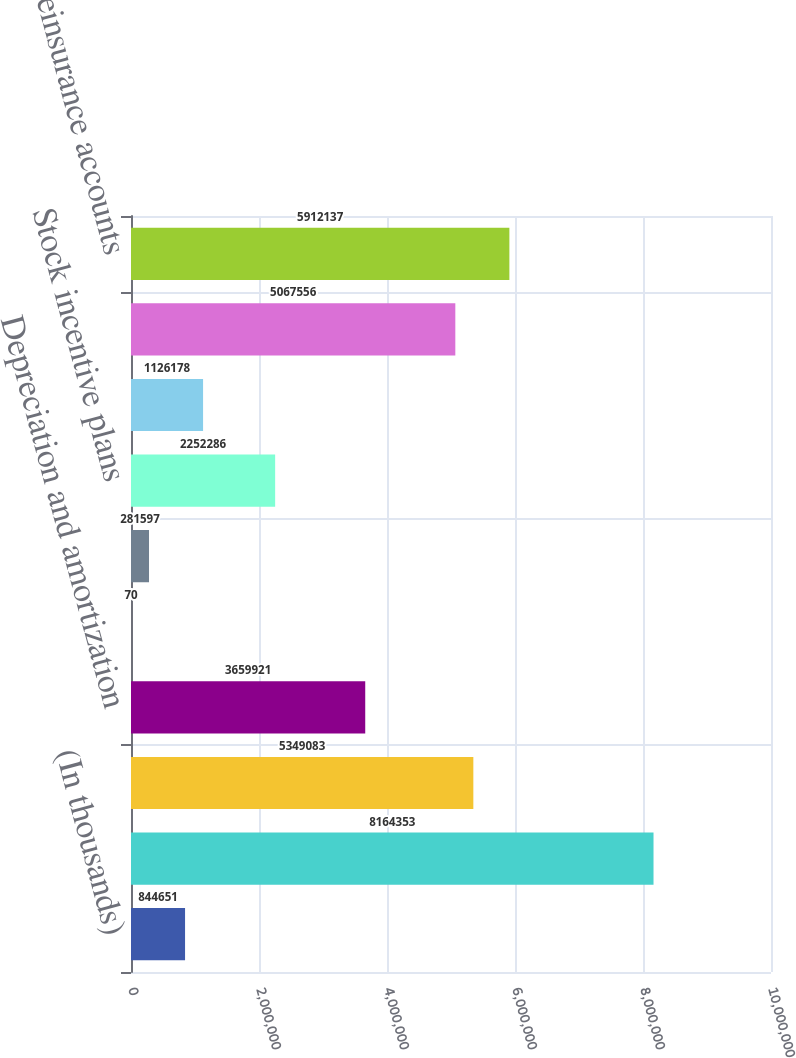Convert chart. <chart><loc_0><loc_0><loc_500><loc_500><bar_chart><fcel>(In thousands)<fcel>Net income to common<fcel>Net investment gains<fcel>Depreciation and amortization<fcel>Noncontrolling interests<fcel>Investment funds<fcel>Stock incentive plans<fcel>Arbitrage trading account<fcel>Premiums and fees receivable<fcel>Reinsurance accounts<nl><fcel>844651<fcel>8.16435e+06<fcel>5.34908e+06<fcel>3.65992e+06<fcel>70<fcel>281597<fcel>2.25229e+06<fcel>1.12618e+06<fcel>5.06756e+06<fcel>5.91214e+06<nl></chart> 